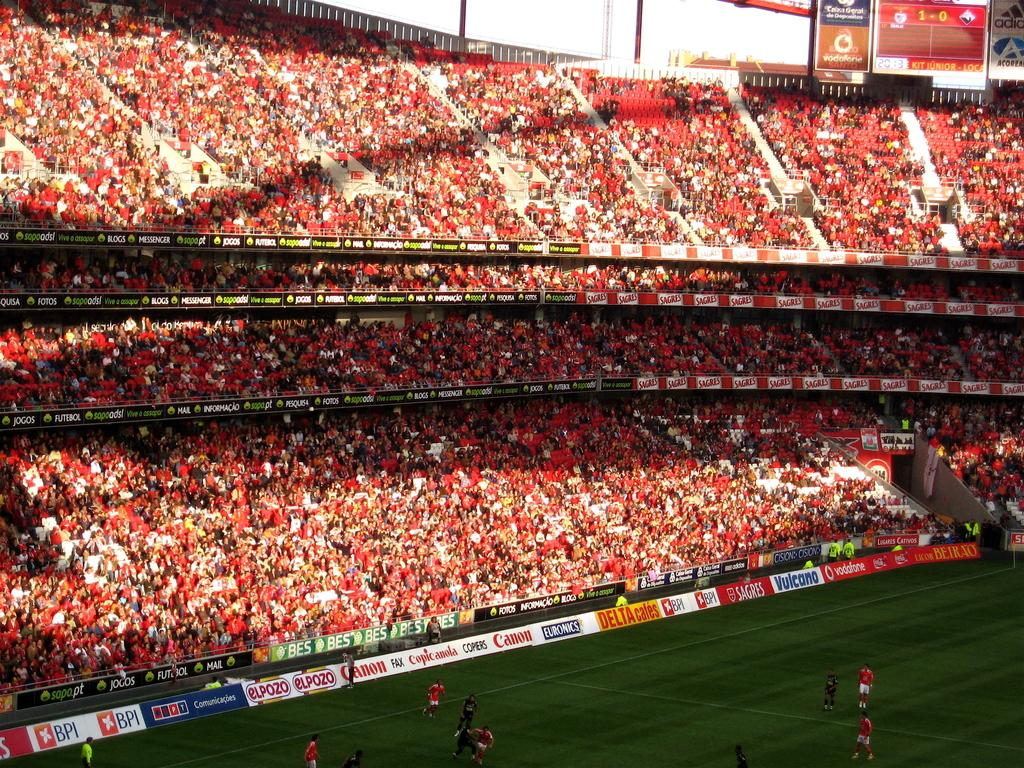<image>
Describe the image concisely. Colorful signs ring the soccer field, including signs for Canon and BPI. 